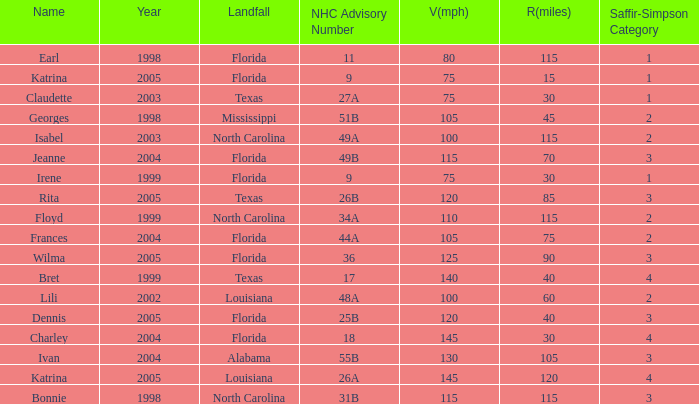What was the lowest V(mph) for a Saffir-Simpson of 4 in 2005? 145.0. 